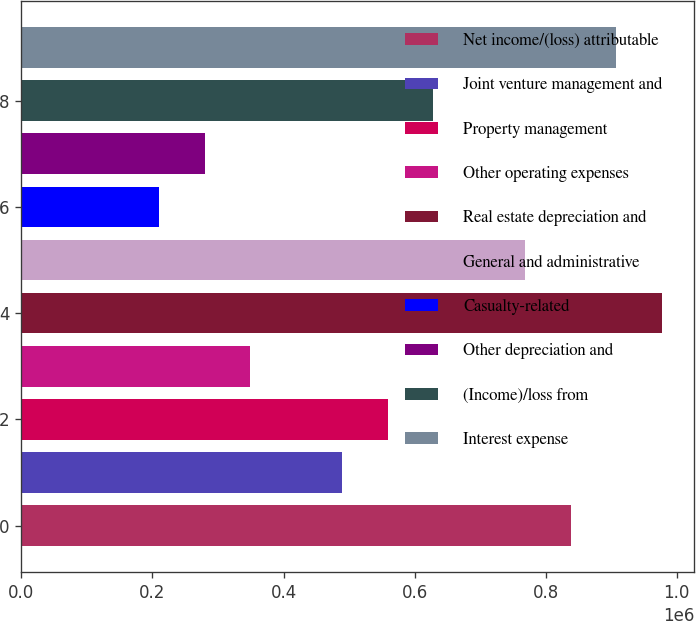Convert chart. <chart><loc_0><loc_0><loc_500><loc_500><bar_chart><fcel>Net income/(loss) attributable<fcel>Joint venture management and<fcel>Property management<fcel>Other operating expenses<fcel>Real estate depreciation and<fcel>General and administrative<fcel>Casualty-related<fcel>Other depreciation and<fcel>(Income)/loss from<fcel>Interest expense<nl><fcel>838171<fcel>489001<fcel>558835<fcel>349334<fcel>977839<fcel>768337<fcel>209666<fcel>279500<fcel>628669<fcel>908005<nl></chart> 